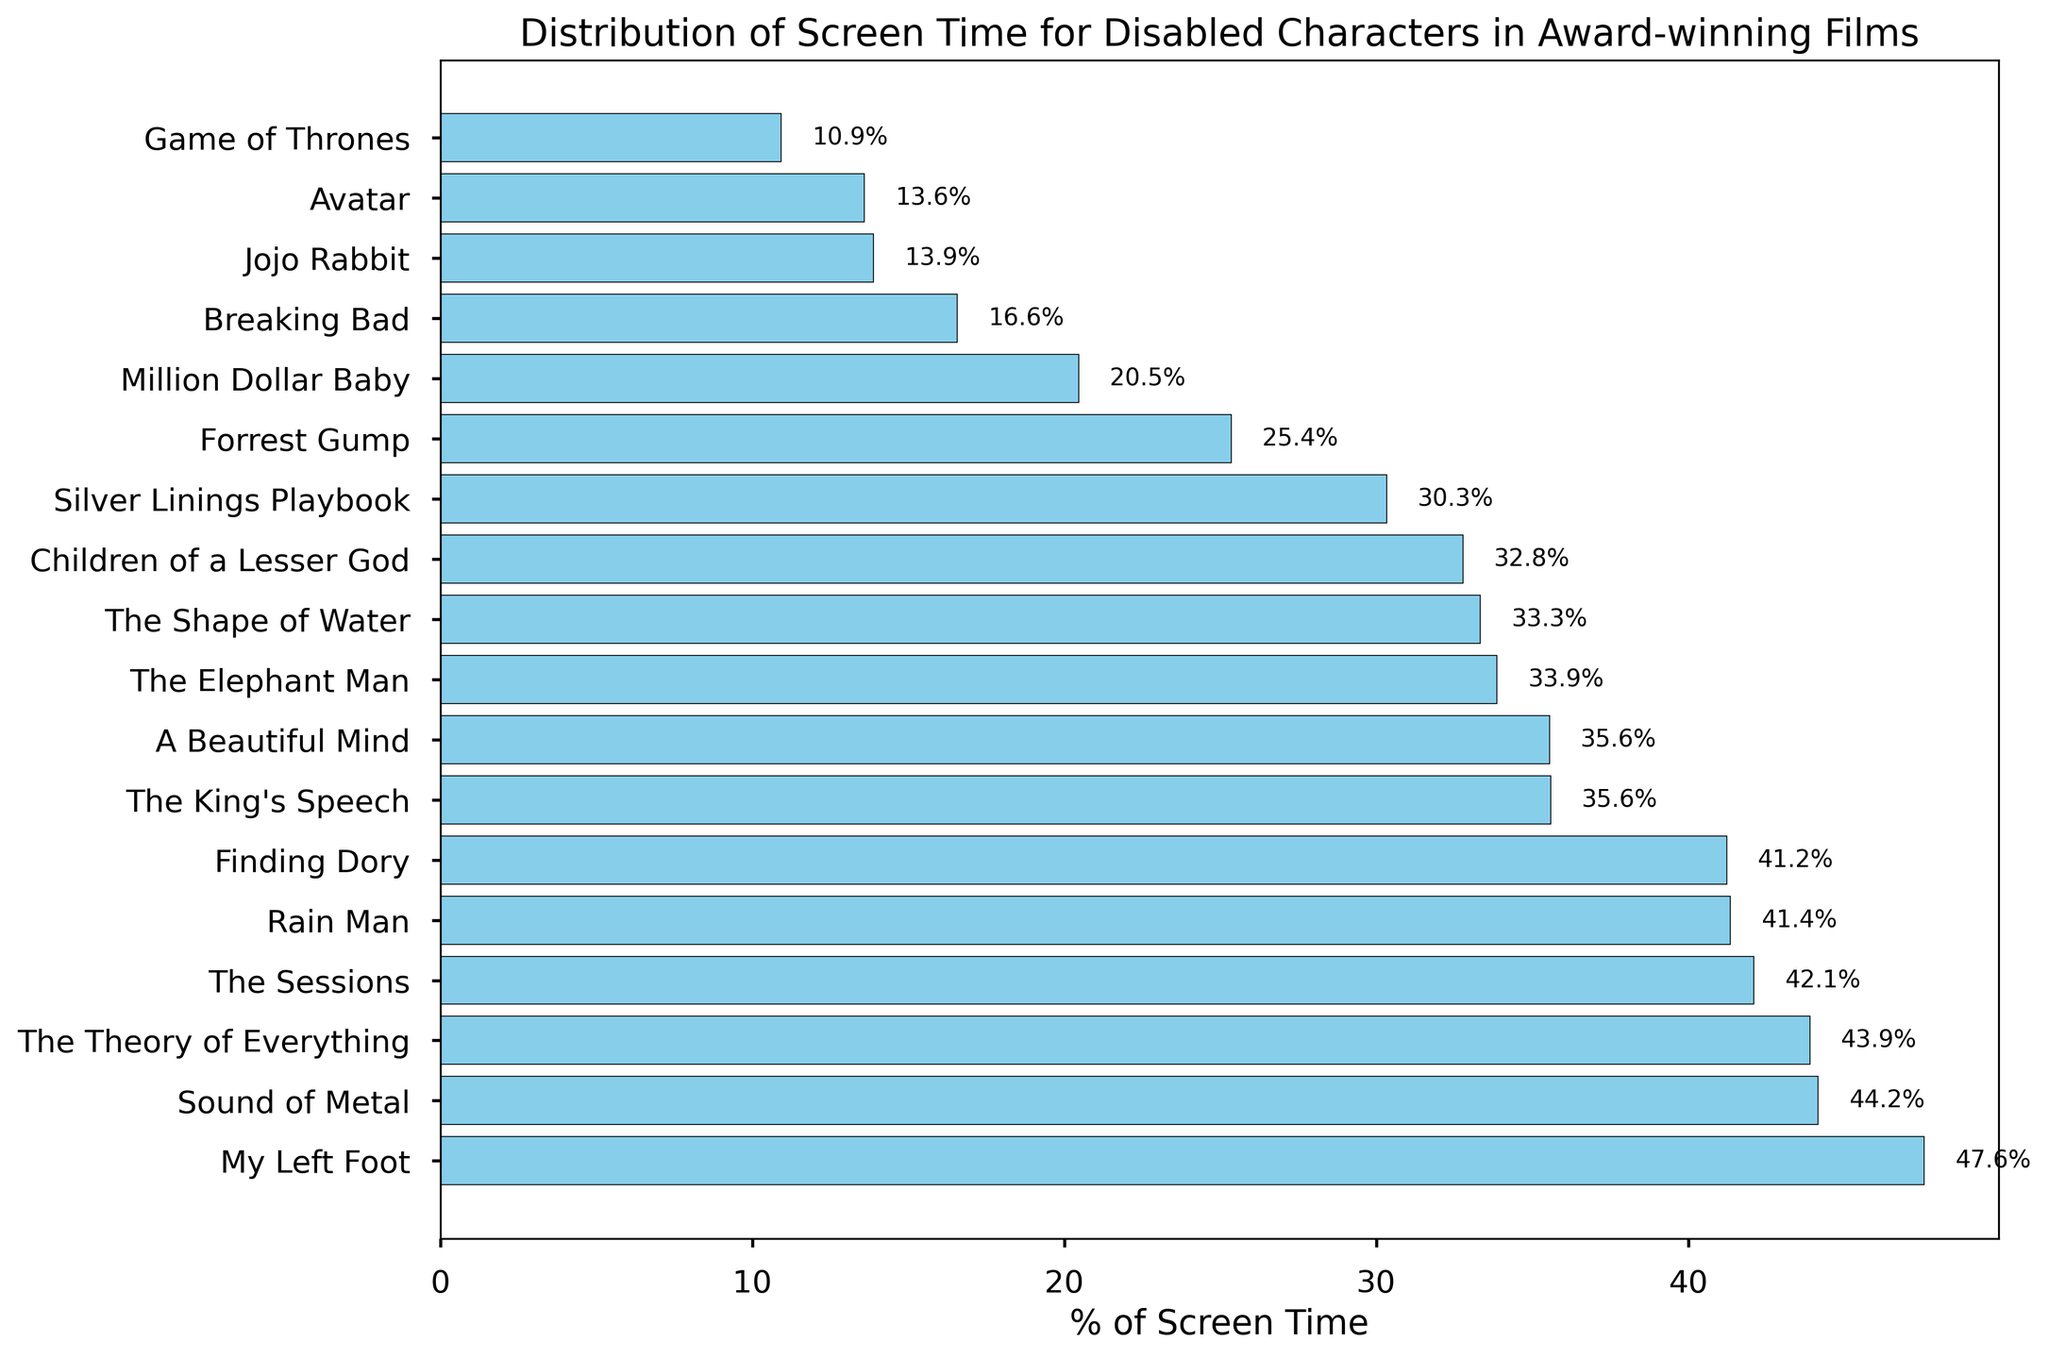What film has the highest percentage of screen time for disabled characters? The film with the highest percentage of screen time for disabled characters will be at the top of the sorted bar chart. Look for the bar at the top position.
Answer: Breaking Bad What is the percentage of screen time for disabled characters in "Forrest Gump" compared to "Rain Man"? Locate the bars for both "Forrest Gump" and "Rain Man". Read the percentage values from the end of the bars and compare them.
Answer: 25.4% vs 41.4% How does the screen time percentage for "The Theory of Everything" compare to "The King's Speech"? Find the bars corresponding to "The Theory of Everything" and "The King's Speech". Note the percentage values for both and compare them directly.
Answer: 43.9% vs 35.6% What is the median percentage of screen time for disabled characters across all films? Order the films by their percentage of screen time. To find the median, locate the middle value of this ordered list. If there is an even number, calculate the average of the two middle numbers.
Answer: 37.5% Which film has the lowest percentage of screen time for disabled characters? The film with the lowest percentage will be at the bottom of the sorted bar chart. Look for the bar at the bottom position.
Answer: Jojo Rabbit Between "A Beautiful Mind" and "Forrest Gump," which film gives more screen time percentage to its disabled character? Locate the bars for "A Beautiful Mind" and "Forrest Gump". Compare the percentage values indicated.
Answer: A Beautiful Mind What is the total percentage of screen time for disabled characters in "Game of Thrones"? Locate the bar for "Game of Thrones" and read the percentage value at the end of the bar.
Answer: 10.9% How does the percentage of screen time in "My Left Foot" compare to that in "Million Dollar Baby"? Find the bars for "My Left Foot" and "Million Dollar Baby". Note the percentage values and compare them directly.
Answer: 47.6% vs 20.5% Which two films have the closest percentages of screen time for their disabled characters? Visually inspect the bars to find two bars that are closest in terms of length. Compare their percentage values to confirm.
Answer: Children of a Lesser God and The Elephant Man Of the films listed, which gave more than 40% of the screen time to their disabled characters? Look for bars that extend past the 40% mark on the x-axis. Identify all films that meet this criterion.
Answer: Rain Man, My Left Foot, The Theory of Everything, Sound of Metal 